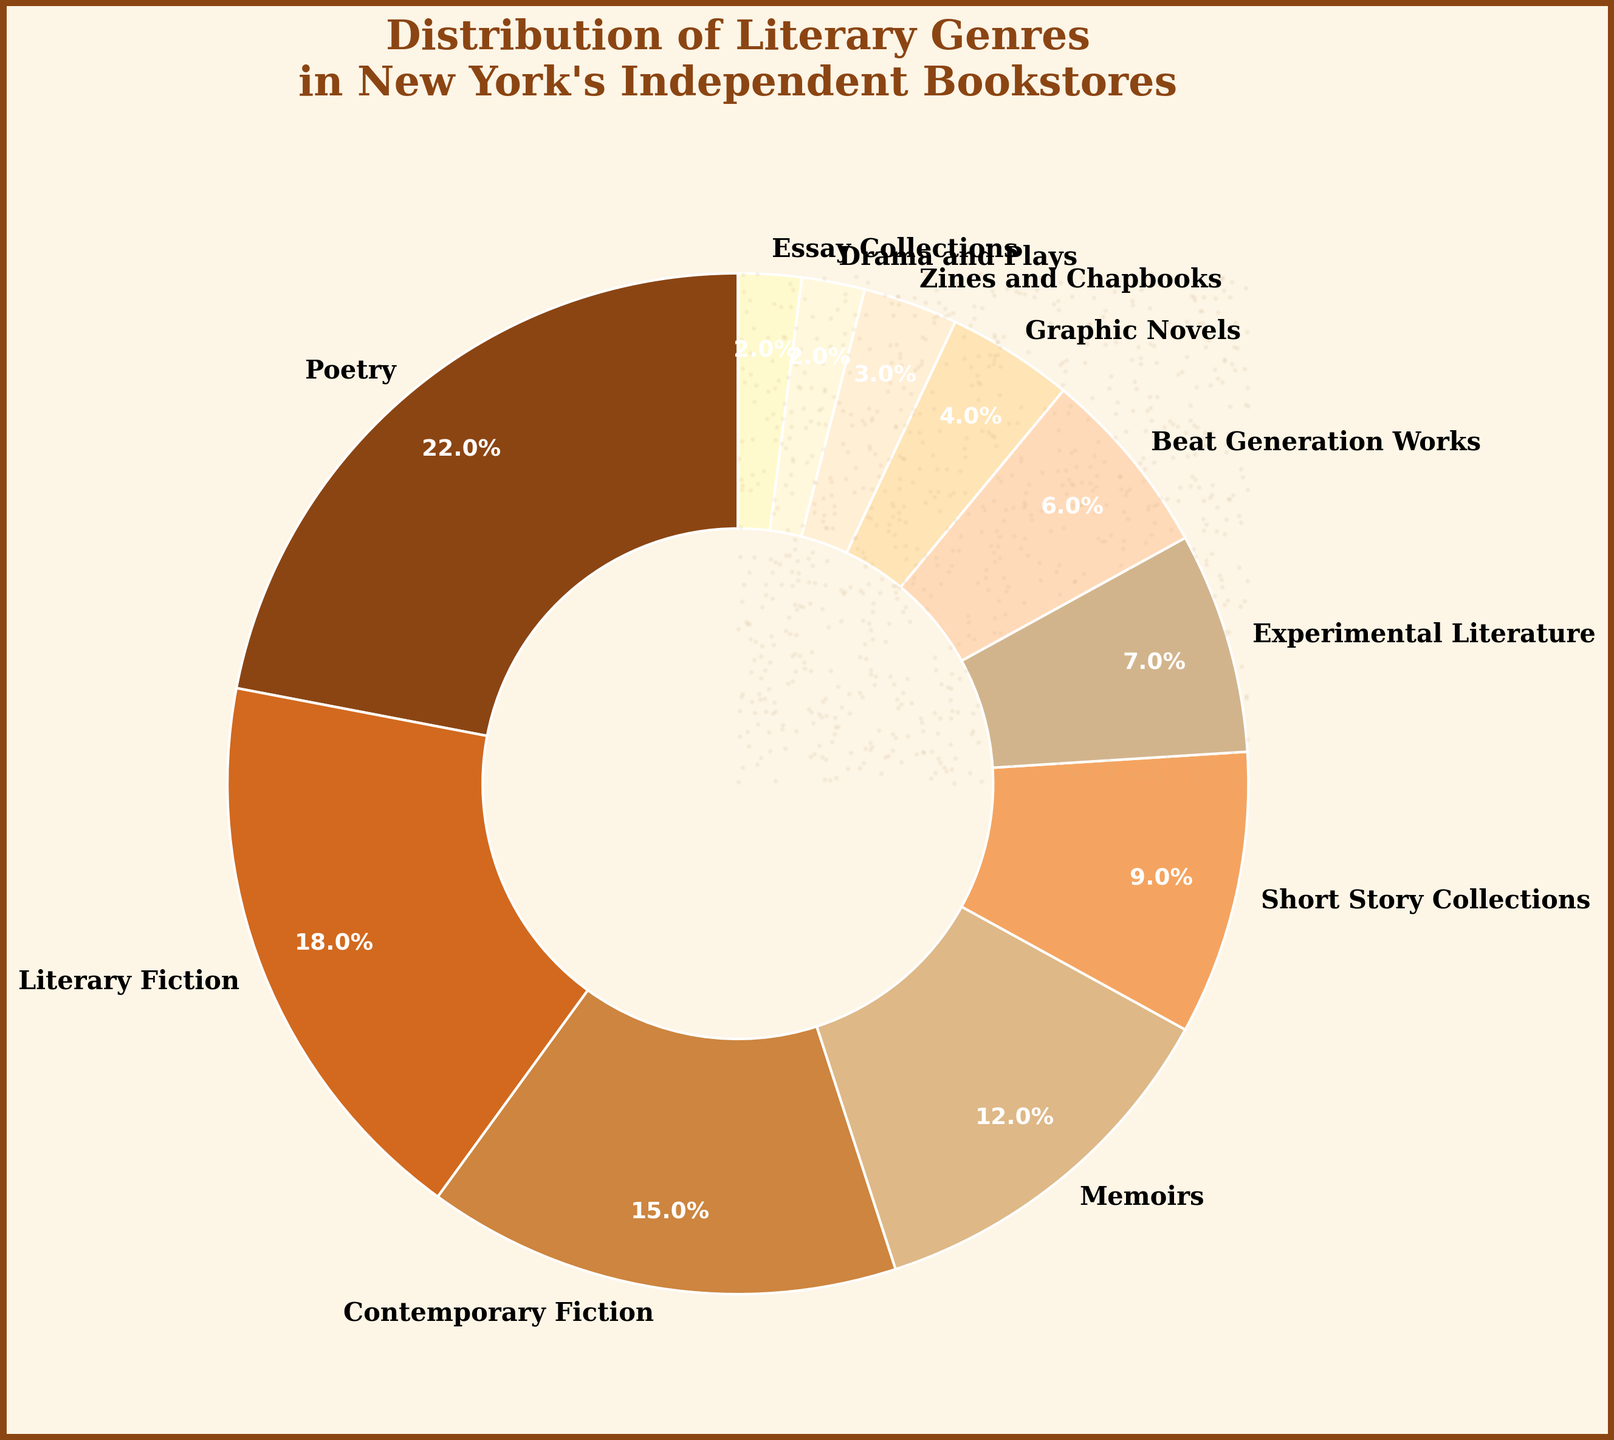What's the total percentage of books dedicated to literary fiction, contemporary fiction, and memoirs? Add the percentages for literary fiction, contemporary fiction, and memoirs: 18% + 15% + 12% = 45%
Answer: 45% Which genre has the smallest representation in New York's independent bookstores? Identify the genre with the smallest percentage from the chart, which is drama and plays at 2%
Answer: Drama and Plays Between poetry and literary fiction, which genre has a higher percentage, and by how much? Compare the percentages for poetry (22%) and literary fiction (18%). Poetry has a higher percentage by 22% - 18% = 4%
Answer: Poetry, by 4% How do the combined percentages of short story collections and experimental literature compare to the percentage of memoirs? Add the percentages for short story collections and experimental literature: 9% + 7% = 16%. Compare this to memoirs at 12%. 16% is greater than 12% by 4%
Answer: Combined, 4% higher What is the median percentage value of all genres listed? Arrange the percentages in ascending order and find the middle value. The sorted list is [2, 2, 3, 4, 6, 7, 9, 12, 15, 18, 22]. The median is the middle value, which is 7%
Answer: 7% Which genre has a darker shade of color in the chart? Identify the genre with the darkest color in the visual representation. Poetry is represented by the darkest shade (dark brown)
Answer: Poetry If you sum the percentages of zines and chapbooks, beat generation works, and graphic novels, do they amount to more or less than short story collections? Calculate the sum: 3% (zines and chapbooks) + 6% (beat generation works) + 4% (graphic novels) = 13%. Compare this sum to short story collections at 9%. 13% is greater than 9%
Answer: More, 13% What is the difference in percentage between the genre with the highest representation and the one with the lowest? Find the difference between the highest (poetry at 22%) and the lowest (drama and plays at 2%): 22% - 2% = 20%
Answer: 20% How does the percentage of essay collections compare to drama and plays? Both essay collections and drama and plays have the same percentage at 2% each
Answer: Equal What genres combined make up exactly 35% of the distribution? Combine percentages to see which sums yield exactly 35%. For example, literary fiction (18%) + contemporary fiction (15%) + drama and plays (2%) = 35%
Answer: Literary Fiction, Contemporary Fiction, Drama and Plays 